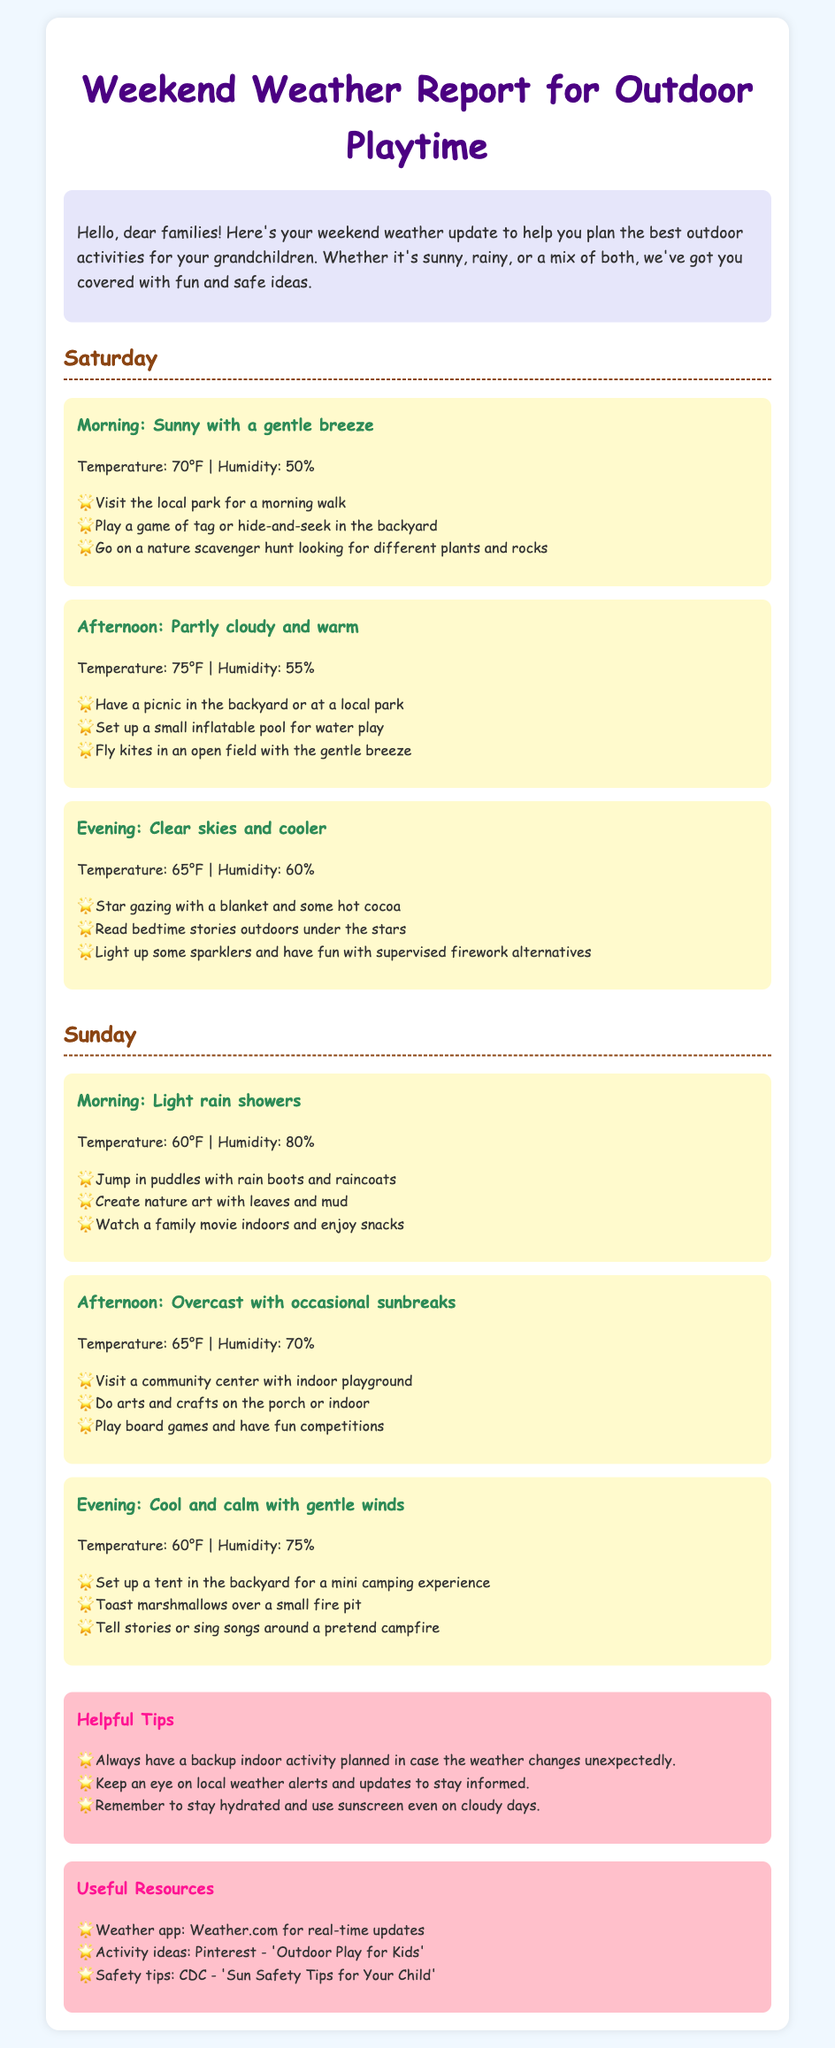What activities are suggested for a sunny Saturday morning? The document lists specific activities for Saturday morning under the sunny weather section, where you can visit the local park, play tag or hide-and-seek, or go on a nature scavenger hunt.
Answer: Visit the local park, play tag or hide-and-seek, go on a nature scavenger hunt What is the temperature forecast for Sunday afternoon? The document provides the temperature forecast for Sunday afternoon, which is mentioned in the weather description.
Answer: 65°F What is a recommended activity for a rainy Sunday morning? The document lists activities for a rainy Sunday morning, specifically mentioning jumping in puddles, creating nature art, or watching a family movie.
Answer: Jump in puddles What is the humidity level during Saturday afternoon? The document provides specific details about Saturday afternoon's weather, including the humidity level.
Answer: 55% What is one tip mentioned for planning outdoor activities? The document includes a section with helpful tips for planning outdoor activities and mentions keeping a backup indoor plan.
Answer: Have a backup indoor activity planned What is the weather condition for Saturday evening? The document describes the weather condition for Saturday evening, specifically that it is clear skies and cooler, along with the temperature.
Answer: Clear skies and cooler What activity is suggested for the evening on Sunday? The document suggests specific activities for Sunday evening, including setting up a tent for camping or toasting marshmallows.
Answer: Set up a tent in the backyard What are the three useful resources mentioned in the document? The document lists useful resources tailored for outdoor playtime and weather updates.
Answer: Weather.com, Pinterest, CDC What is the humidity during Sunday evening? The document specifies the humidity for Sunday evening, giving that information in the weather section.
Answer: 75% 